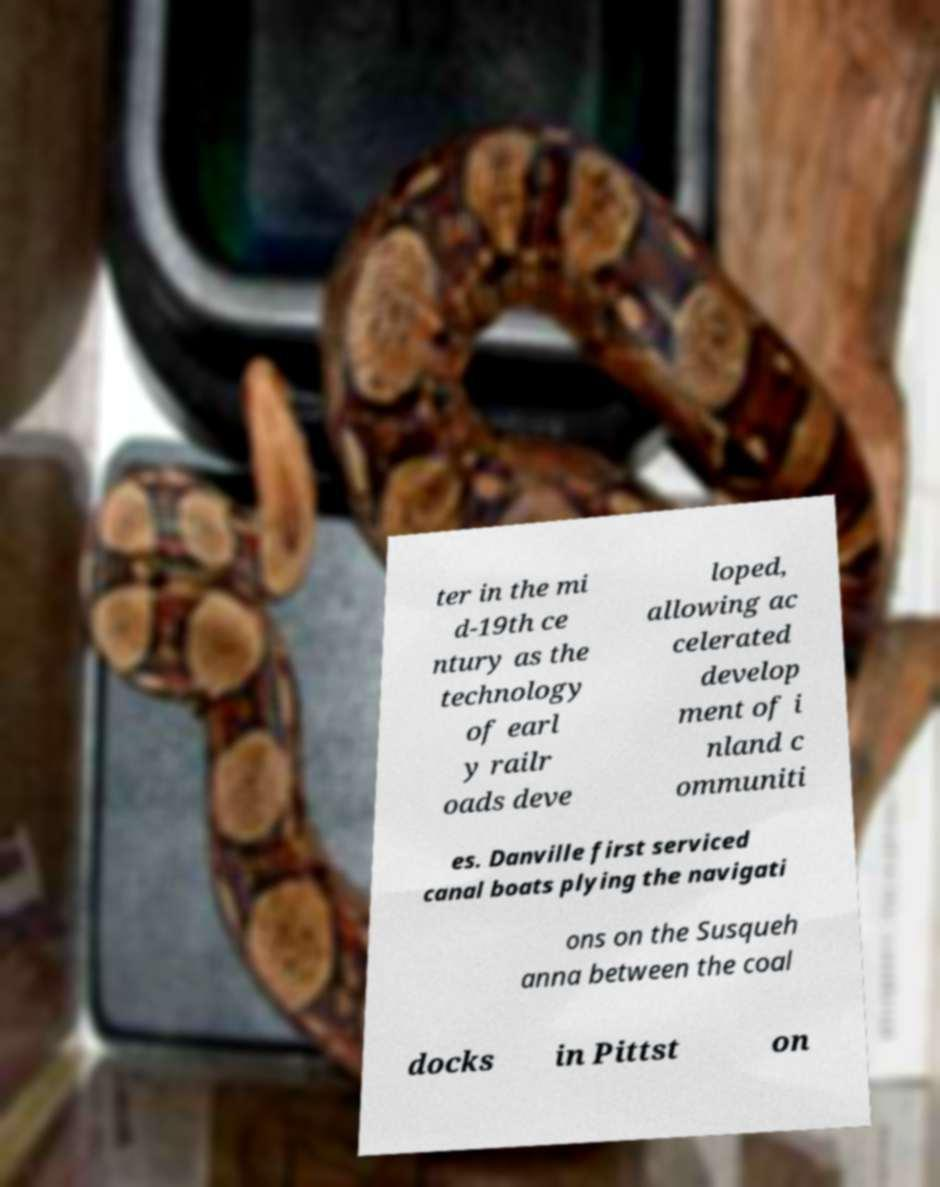Can you read and provide the text displayed in the image?This photo seems to have some interesting text. Can you extract and type it out for me? ter in the mi d-19th ce ntury as the technology of earl y railr oads deve loped, allowing ac celerated develop ment of i nland c ommuniti es. Danville first serviced canal boats plying the navigati ons on the Susqueh anna between the coal docks in Pittst on 